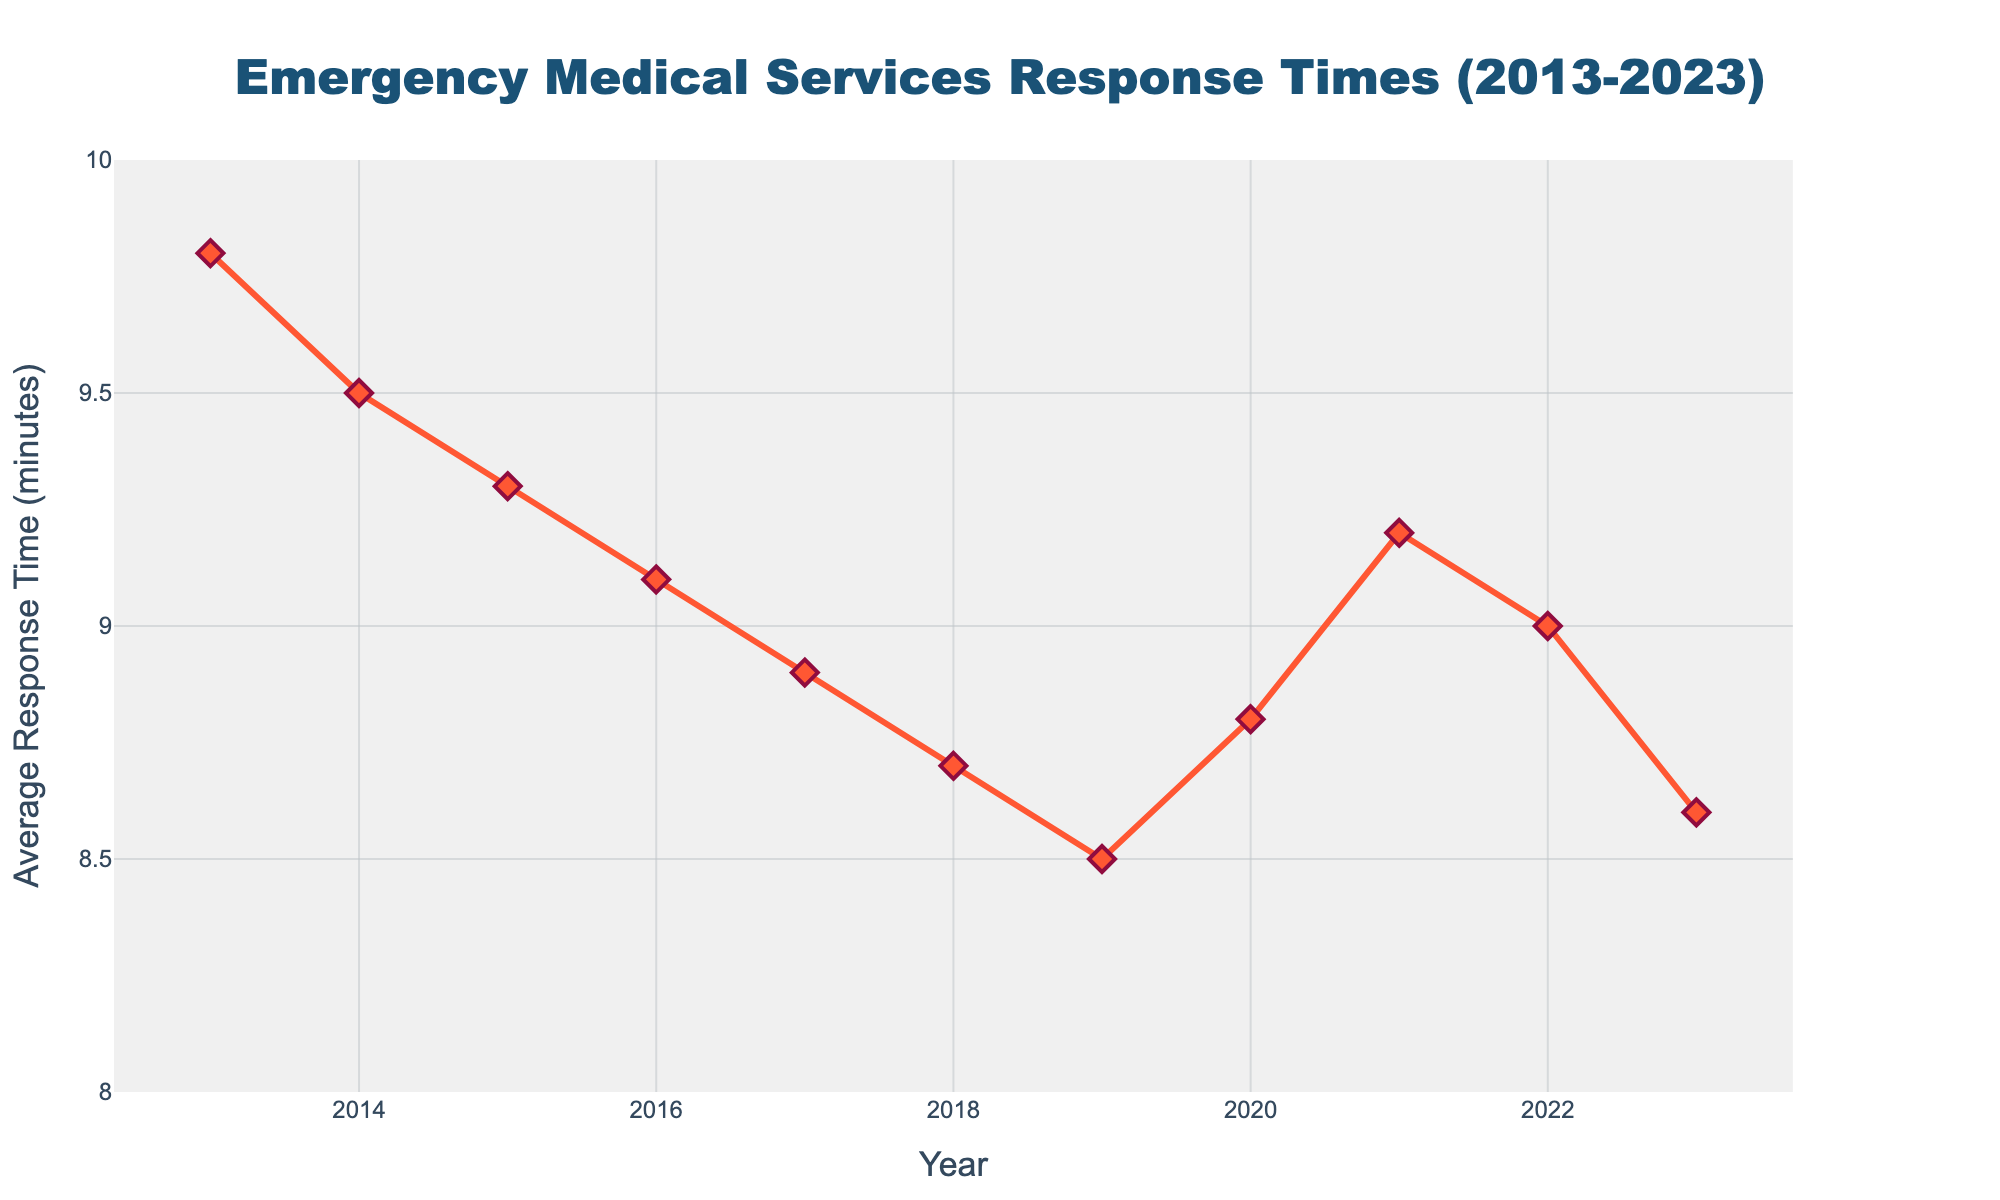What's the trend of the average response times from 2013 to 2023? To determine the trend, look at the line chart from 2013 to 2023. From 2013 (9.8 minutes) to 2019 (8.5 minutes), there's a decreasing trend. In 2020, the response time slightly increased to 8.8 minutes. From 2021 (9.2 minutes) to 2023 (8.6 minutes), there's again a decreasing trend. Overall, there's a general decreasing trend with minor fluctuations.
Answer: Decreasing What's the average response time over the entire period? First, add the response times for each year: 9.8 + 9.5 + 9.3 + 9.1 + 8.9 + 8.7 + 8.5 + 8.8 + 9.2 + 9.0 + 8.6. This sums to 98.4 minutes. There are 11 years, so divide the total by 11: 98.4 / 11.
Answer: 8.9 minutes Which year had the highest average response time and what was it? Locate the highest point on the line chart. The peak value appears in 2013 at 9.8 minutes.
Answer: 2013, 9.8 minutes Compare the average response time of 2019 to that of 2021. Which one is higher, and by how much? Check the values for 2019 (8.5 minutes) and 2021 (9.2 minutes). Subtract the lower from the higher: 9.2 - 8.5.
Answer: 2021 is higher by 0.7 minutes What is the median response time over the decade? List the response times: 9.8, 9.5, 9.3, 9.1, 8.9, 8.7, 8.5, 8.8, 9.2, 9.0, 8.6. Sort them: 8.5, 8.6, 8.7, 8.8, 8.9, 9.0, 9.1, 9.2, 9.3, 9.5, 9.8. The median is the middle value: 9.0 minutes.
Answer: 9.0 minutes How does the response time in 2020 compare to that in 2017? Identify the values for 2020 (8.8 minutes) and 2017 (8.9 minutes). Compare and find the difference: 8.9 - 8.8.
Answer: 2017 is higher by 0.1 minutes Identify any years where the average response time increased compared to the previous year. Scan the chart for rising segments. From 2019 to 2020, response time increased (8.5 to 8.8). From 2020 to 2021, response time increased (8.8 to 9.2).
Answer: 2020, 2021 What was the rate of change in response times from 2015 to 2016? Determine the values for 2015 (9.3 minutes) and 2016 (9.1 minutes). Calculate the rate: (9.1 - 9.3) / 9.3. It equals -0.02, which means a 2.15% decrease.
Answer: -2.15% Between which consecutive years was the biggest decrease in response time? Check the year-to-year changes: 2013-2014 (9.8-9.5 = 0.3), 2014-2015 (9.5-9.3 = 0.2), 2015-2016 (9.3-9.1 = 0.2), 2016-2017 (9.1-8.9 = 0.2), 2017-2018 (8.9-8.7 = 0.2), 2018-2019 (8.7-8.5 = 0.2), 2019-2020 (8.8-8.5 = -0.3 increase), 2020-2021 (9.2-8.8 = 0.4), 2021-2022 (9.2-9.0 = 0.2), 2022-2023 (9.0-8.6 = 0.4). The biggest decrease is from 2021 to 2022 or from 2022 to 2023.
Answer: 2021-2022 or 2022-2023 What's the smallest average response time recorded in the last decade? Find the lowest point on the line chart. The lowest value is in 2019 (8.5 minutes).
Answer: 8.5 minutes 